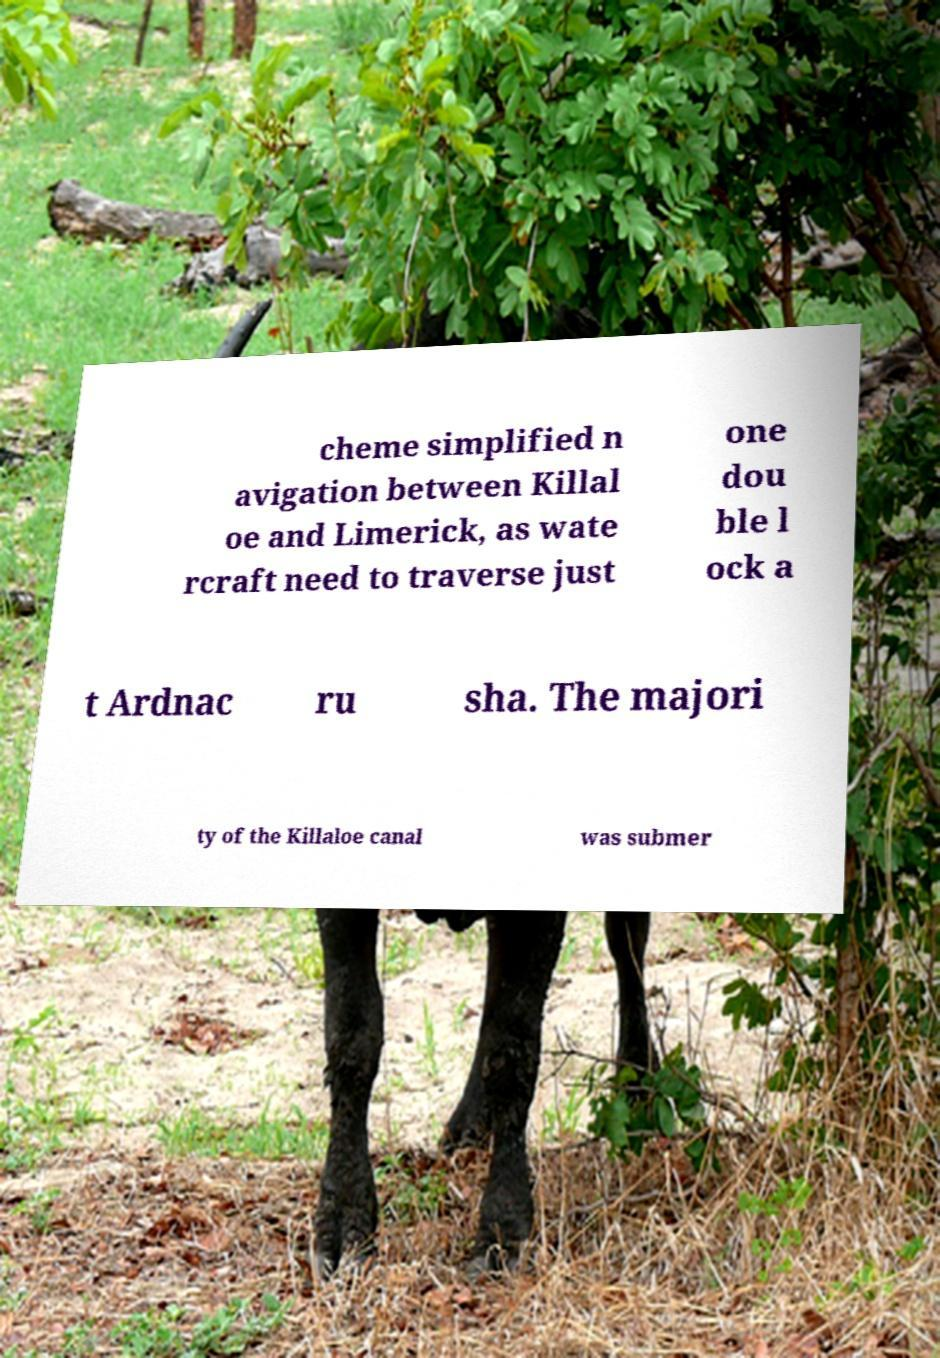I need the written content from this picture converted into text. Can you do that? cheme simplified n avigation between Killal oe and Limerick, as wate rcraft need to traverse just one dou ble l ock a t Ardnac ru sha. The majori ty of the Killaloe canal was submer 